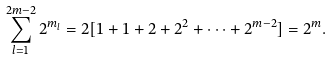Convert formula to latex. <formula><loc_0><loc_0><loc_500><loc_500>\sum _ { l = 1 } ^ { 2 m - 2 } 2 ^ { m _ { l } } = 2 [ 1 + 1 + 2 + 2 ^ { 2 } + \cdots + 2 ^ { m - 2 } ] = 2 ^ { m } .</formula> 